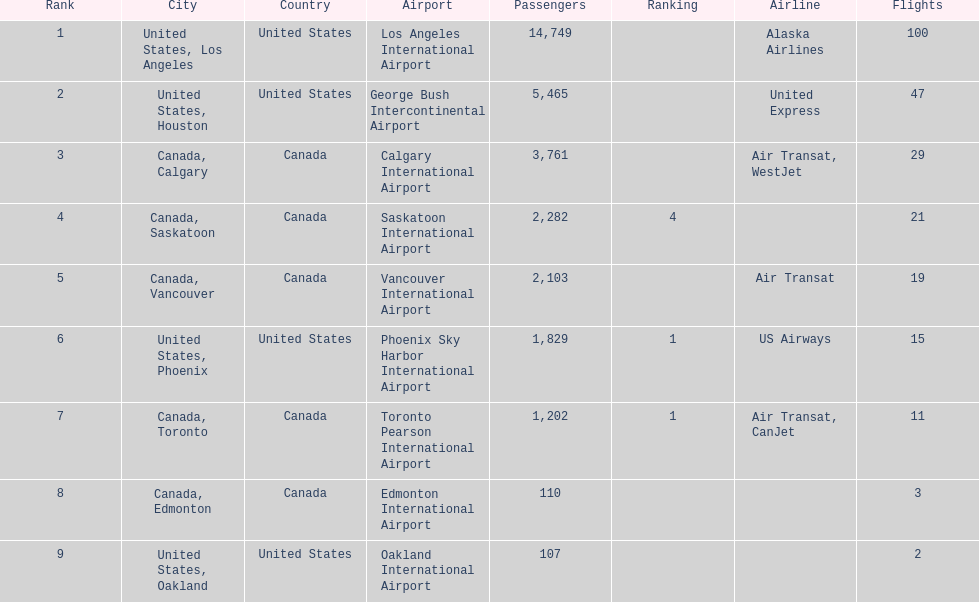What was the number of passengers in phoenix arizona? 1,829. 